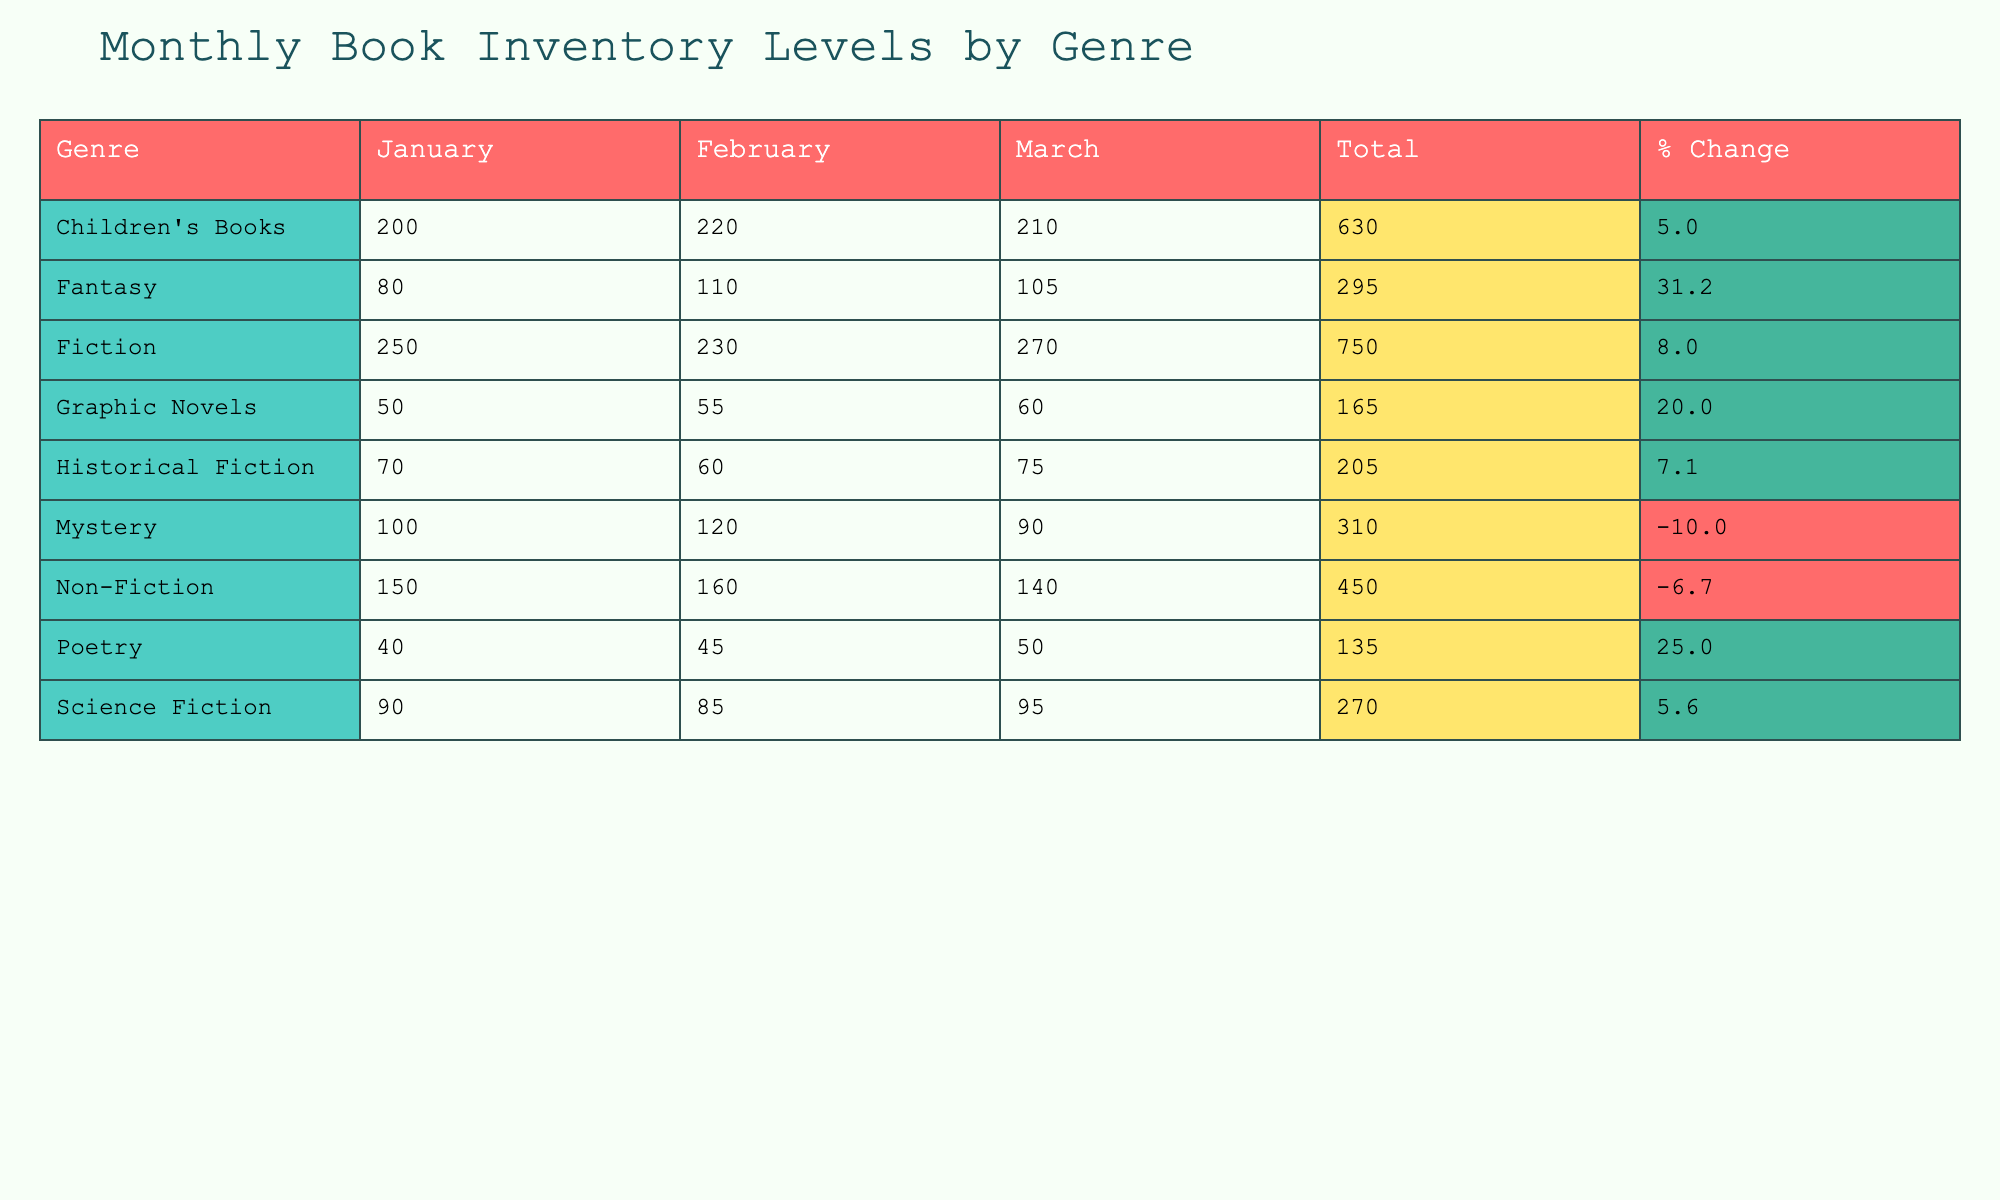What was the inventory level of Fiction in March? The table lists the inventory levels by genre and month. For Fiction, the inventory level in March is explicitly given as 270.
Answer: 270 Which genre had the lowest inventory level in January? By checking the January inventory for each genre, Historical Fiction has an inventory level of 70, which is lower than all other genres listed.
Answer: Historical Fiction What is the total inventory level for Children's Books across all months? To find the total for Children's Books, we add the inventory levels for January (200), February (220), and March (210). The total is 200 + 220 + 210 = 630.
Answer: 630 Is there an increase in inventory levels for Science Fiction from January to March? For Science Fiction, the January inventory is 90, and the March inventory is 95. Since 95 is greater than 90, there is an increase in inventory levels.
Answer: Yes What is the percentage change in inventory from January to March for Fantasy? The January inventory for Fantasy is 80, and the March inventory is 105. The percentage change is calculated as ((105 - 80) / 80) * 100, which equals 31.25%.
Answer: 31.3% How many genres had a total inventory level greater than 300? First, we need to calculate the total for each genre. Only Fiction (750), Fiction (670), and Children's Books (630) exceed 300. Therefore, there are three genres with totals above 300.
Answer: 3 What is the average inventory level of Graphic Novels over the three months? The inventory levels are 50 for January, 55 for February, and 60 for March. The average is calculated as (50 + 55 + 60) / 3, which equals 55.
Answer: 55 Which genre showed a decline in inventory level from January to March? Looking at the table, Mystery and Non-Fiction show declines in inventory from January to March (from 100 to 90 for Mystery, and from 150 to 140 for Non-Fiction).
Answer: Mystery and Non-Fiction What was the highest inventory level in February across all genres? In February, we check each genre's level: Fiction had 230, Non-Fiction 160, Mystery 120, Science Fiction 85, Fantasy 110, Historical Fiction 60, Children's Books 220, Graphic Novels 55, and Poetry 45. The highest is 230 for Fiction.
Answer: 230 